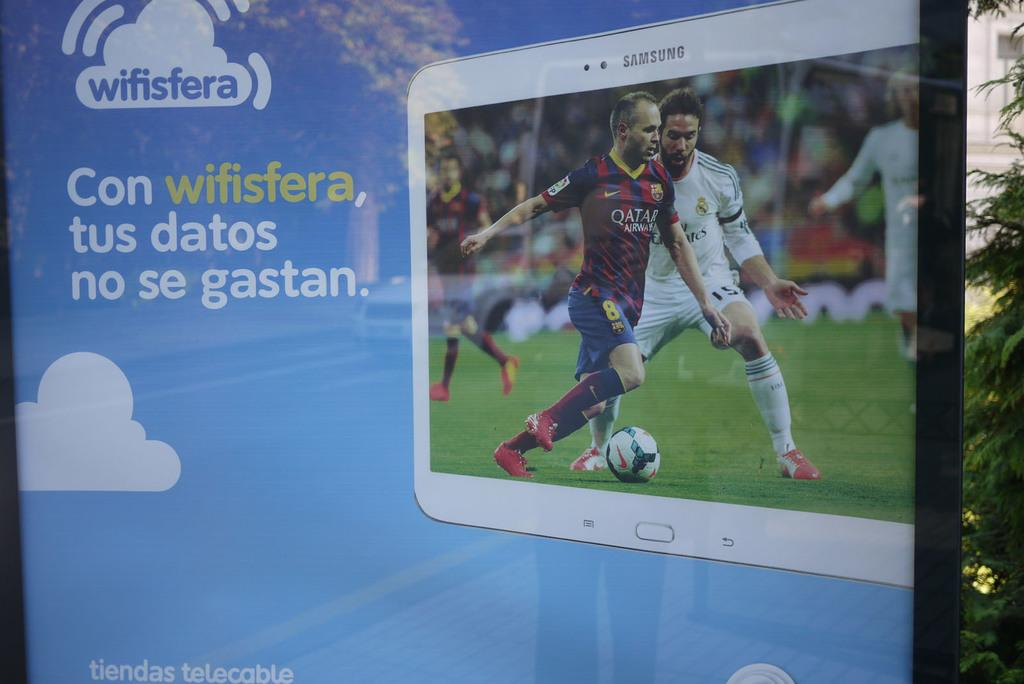What is depicted on the poster in the image? There is a poster of a Samsung tablet in the image. What is being displayed on the tablet? A football game is displayed on the tablet. What color is the poster? The poster is blue in color. What can be seen on the right side of the image? There are trees on the right side of the image. How many tickets are visible on the poster? There are no tickets present on the poster; it features a Samsung tablet with a football game displayed. What type of money is being used to purchase the Samsung tablet in the image? There is no money visible in the image, and the purchase of the tablet is not depicted. 